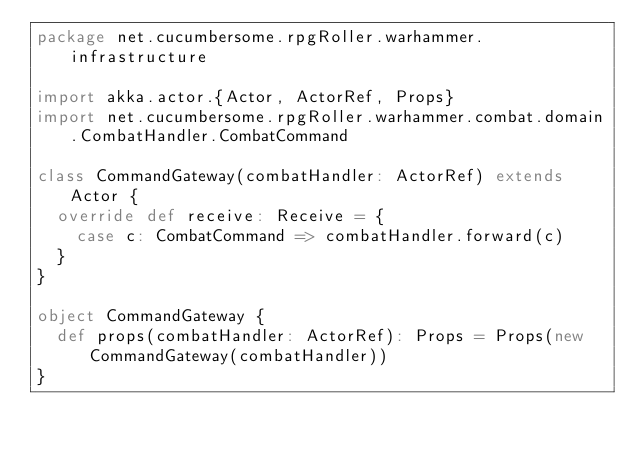<code> <loc_0><loc_0><loc_500><loc_500><_Scala_>package net.cucumbersome.rpgRoller.warhammer.infrastructure

import akka.actor.{Actor, ActorRef, Props}
import net.cucumbersome.rpgRoller.warhammer.combat.domain.CombatHandler.CombatCommand

class CommandGateway(combatHandler: ActorRef) extends Actor {
  override def receive: Receive = {
    case c: CombatCommand => combatHandler.forward(c)
  }
}

object CommandGateway {
  def props(combatHandler: ActorRef): Props = Props(new CommandGateway(combatHandler))
}
</code> 